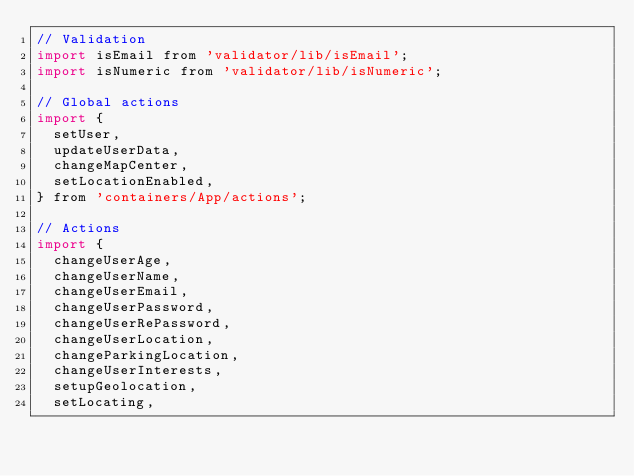Convert code to text. <code><loc_0><loc_0><loc_500><loc_500><_JavaScript_>// Validation
import isEmail from 'validator/lib/isEmail';
import isNumeric from 'validator/lib/isNumeric';

// Global actions
import {
  setUser,
  updateUserData,
  changeMapCenter,
  setLocationEnabled,
} from 'containers/App/actions';

// Actions
import {
  changeUserAge,
  changeUserName,
  changeUserEmail,
  changeUserPassword,
  changeUserRePassword,
  changeUserLocation,
  changeParkingLocation,
  changeUserInterests,
  setupGeolocation,
  setLocating,</code> 